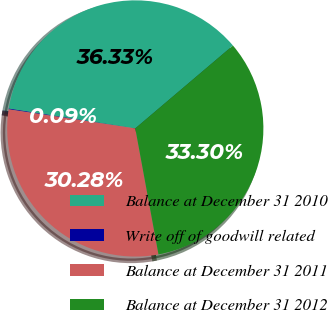Convert chart to OTSL. <chart><loc_0><loc_0><loc_500><loc_500><pie_chart><fcel>Balance at December 31 2010<fcel>Write off of goodwill related<fcel>Balance at December 31 2011<fcel>Balance at December 31 2012<nl><fcel>36.33%<fcel>0.09%<fcel>30.28%<fcel>33.3%<nl></chart> 